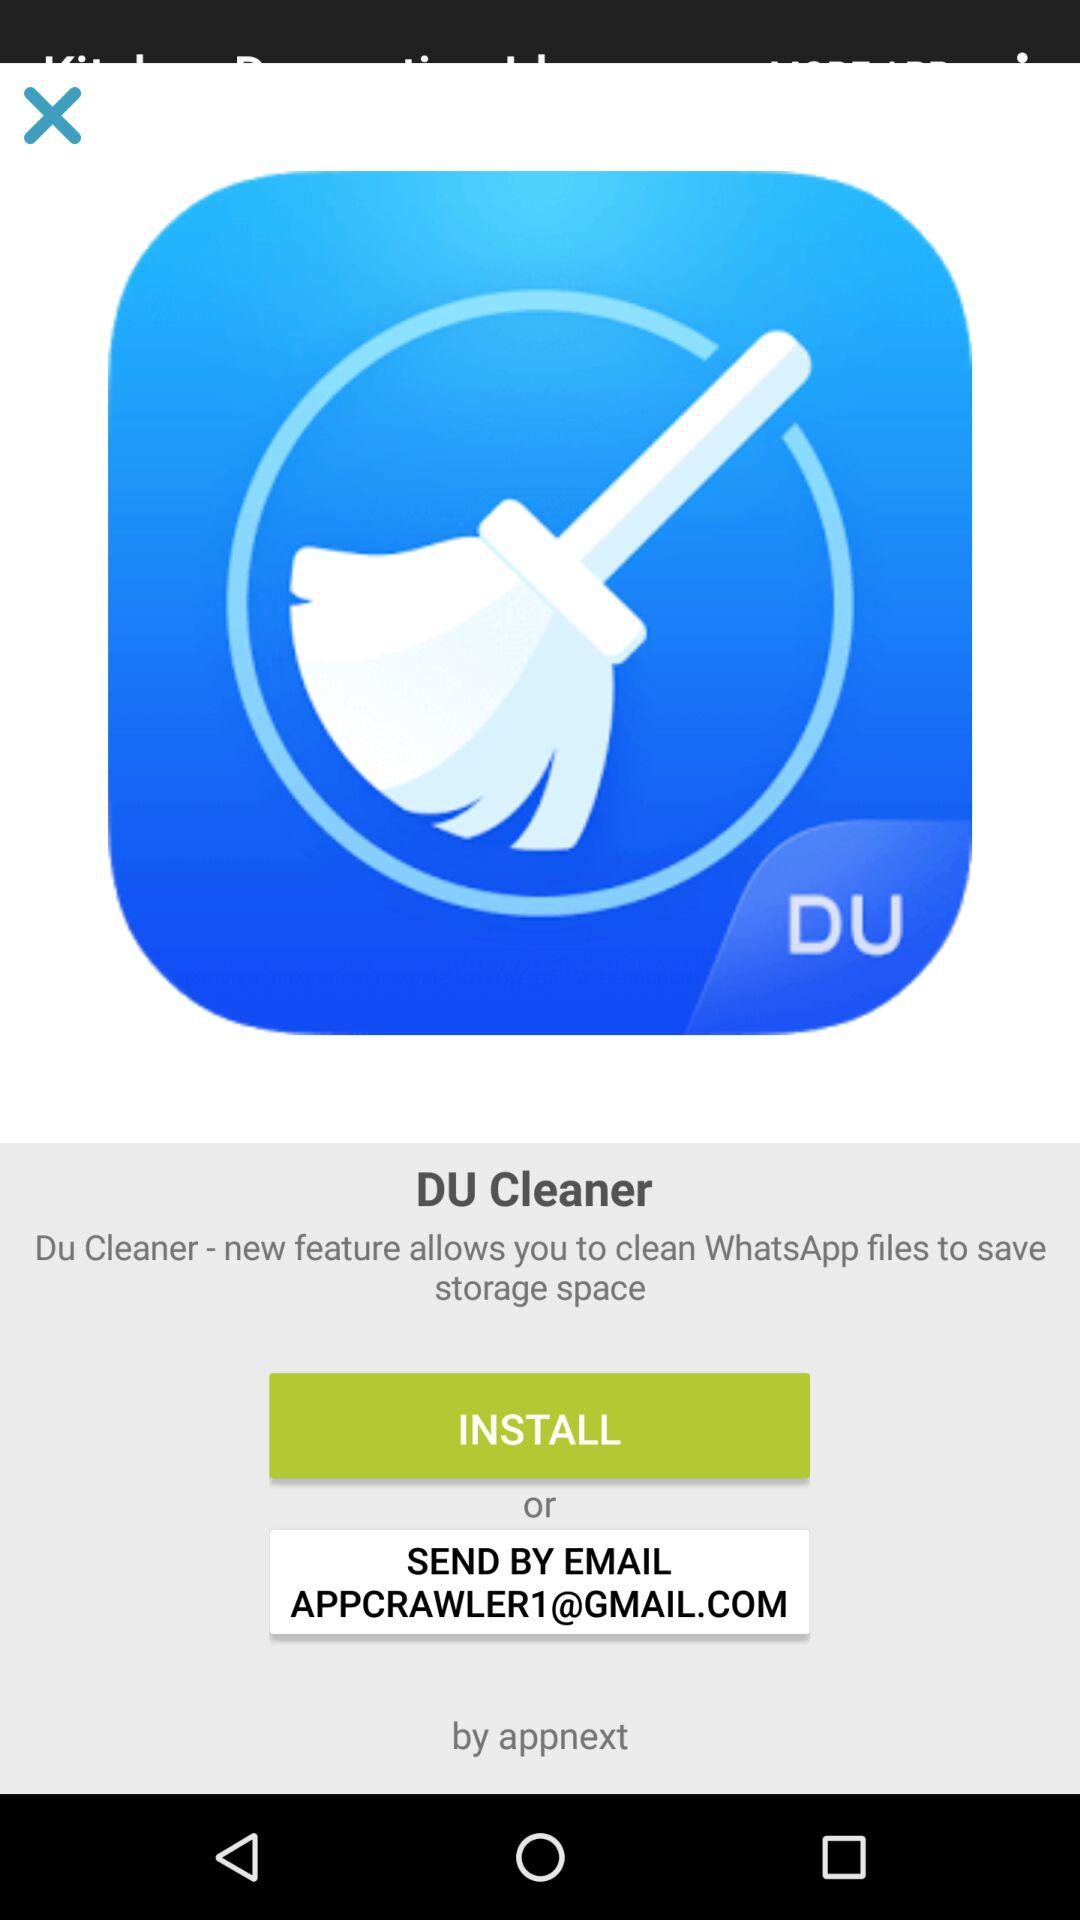What is the email address? The email address is APPCRAWLER1@GMAIL.COM. 